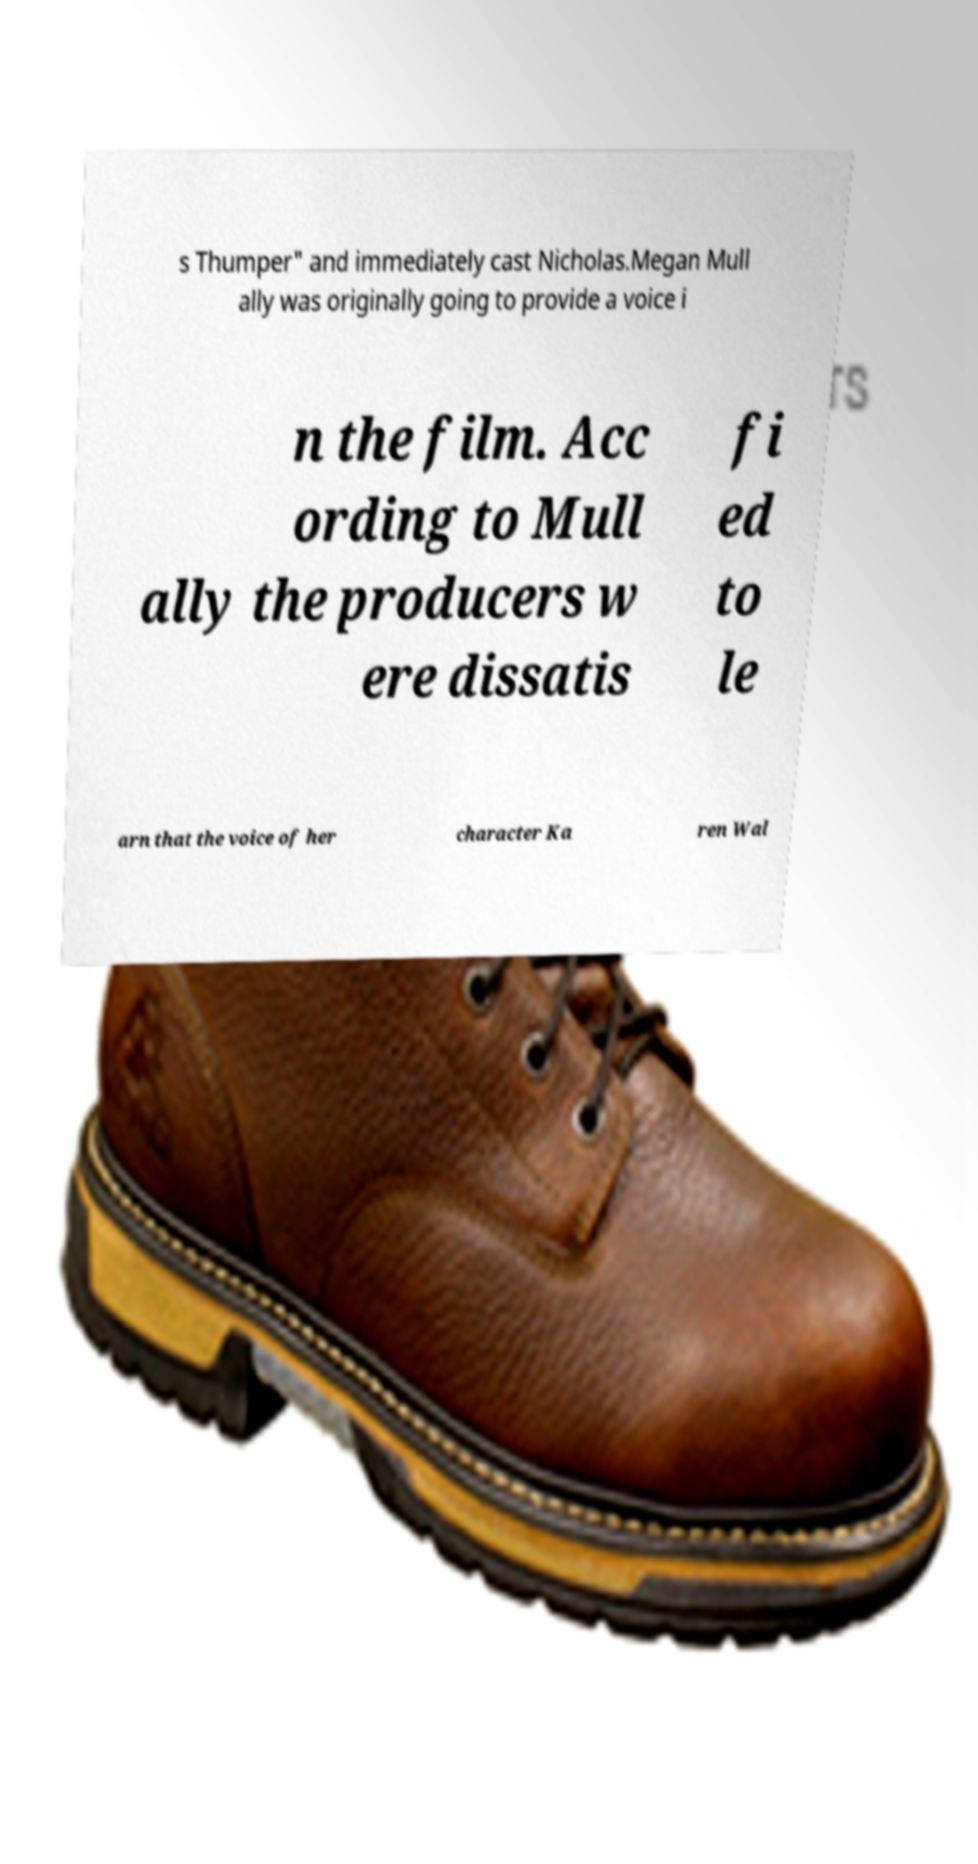Please identify and transcribe the text found in this image. s Thumper" and immediately cast Nicholas.Megan Mull ally was originally going to provide a voice i n the film. Acc ording to Mull ally the producers w ere dissatis fi ed to le arn that the voice of her character Ka ren Wal 